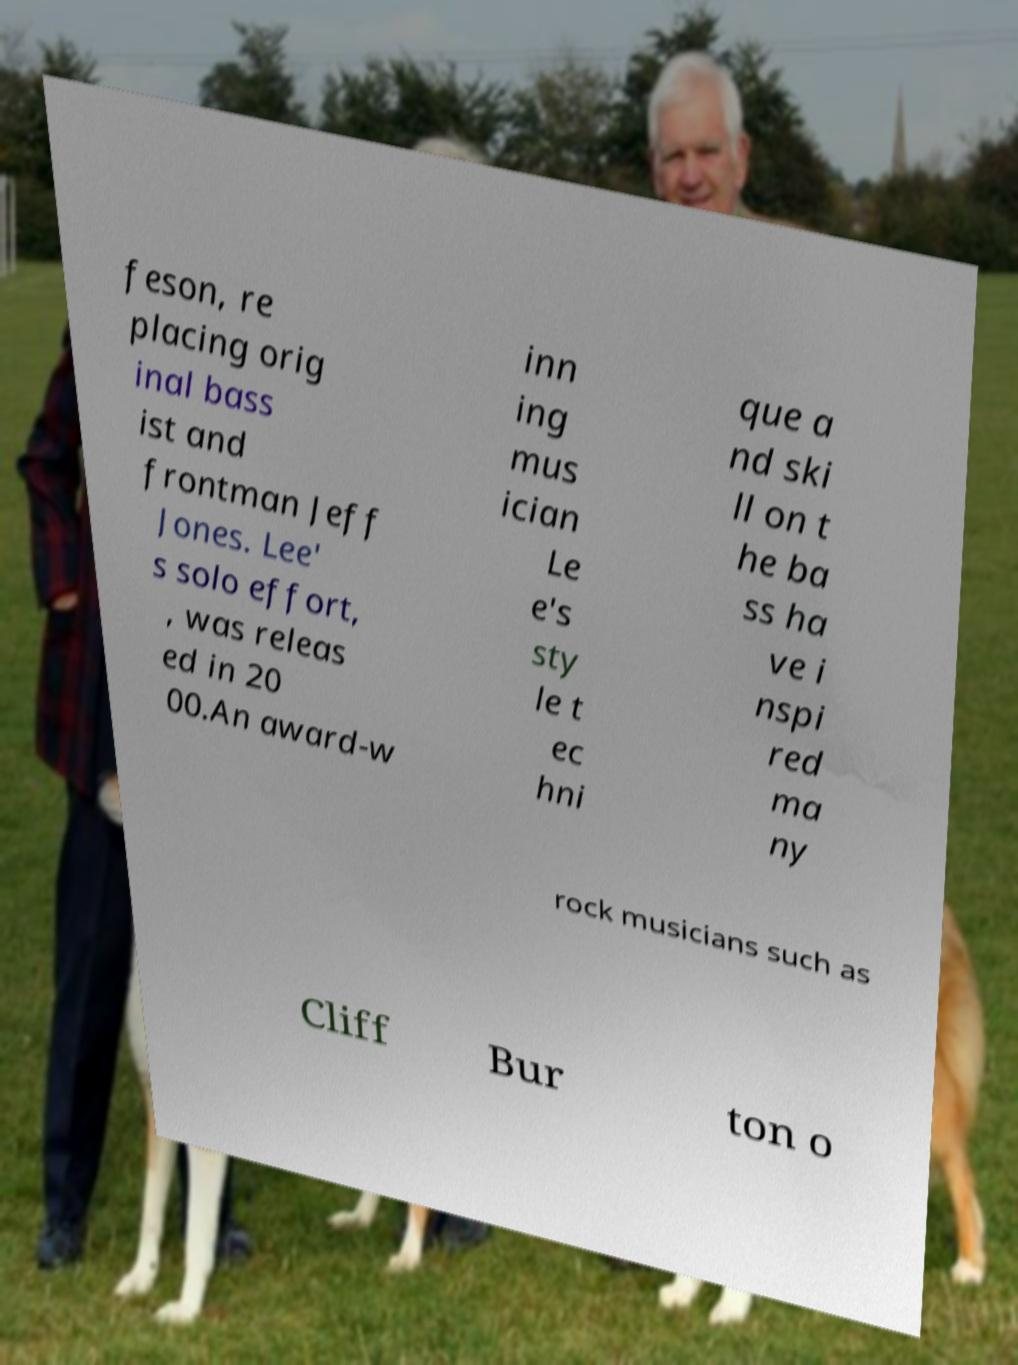What messages or text are displayed in this image? I need them in a readable, typed format. feson, re placing orig inal bass ist and frontman Jeff Jones. Lee' s solo effort, , was releas ed in 20 00.An award-w inn ing mus ician Le e's sty le t ec hni que a nd ski ll on t he ba ss ha ve i nspi red ma ny rock musicians such as Cliff Bur ton o 